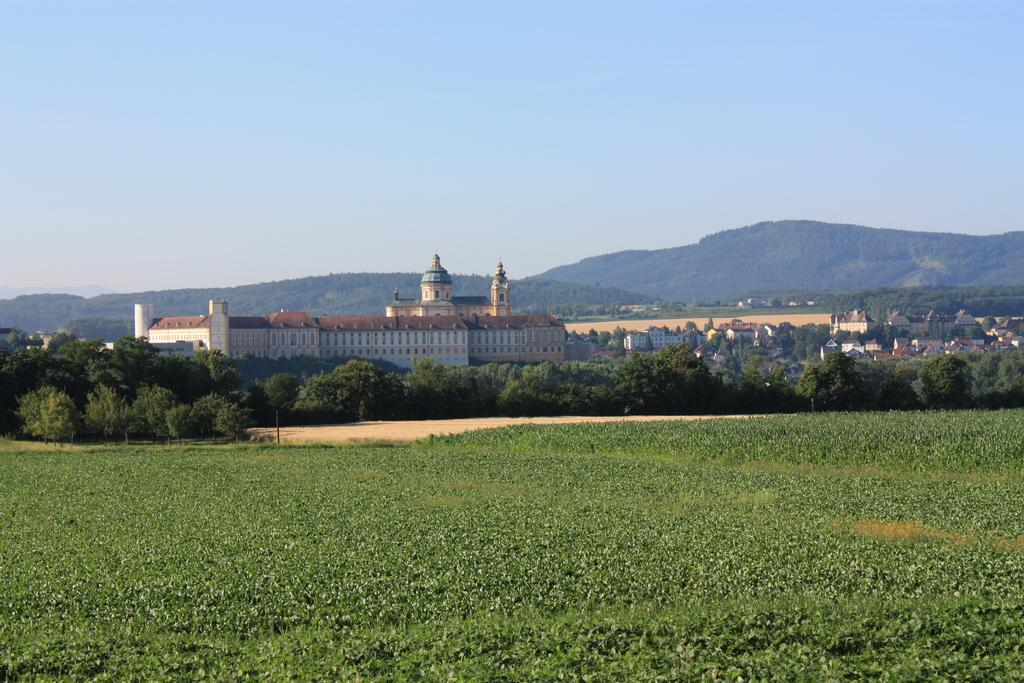What is located in the foreground of the image? There are plants in the foreground of the image. What can be seen in the background of the image? There are buildings, trees, and hills in the background of the image. What is visible in the sky in the image? There are clouds visible in the sky. What is the history of the light source in the image? There is no light source mentioned in the image, as it only features plants, buildings, trees, hills, and clouds. What is the purpose of the trees in the image? The trees in the image do not have a specific purpose mentioned, as they are simply part of the natural landscape. 